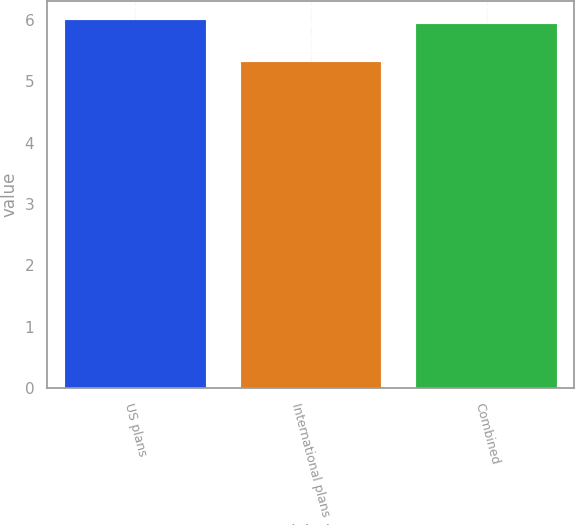<chart> <loc_0><loc_0><loc_500><loc_500><bar_chart><fcel>US plans<fcel>International plans<fcel>Combined<nl><fcel>6<fcel>5.31<fcel>5.93<nl></chart> 